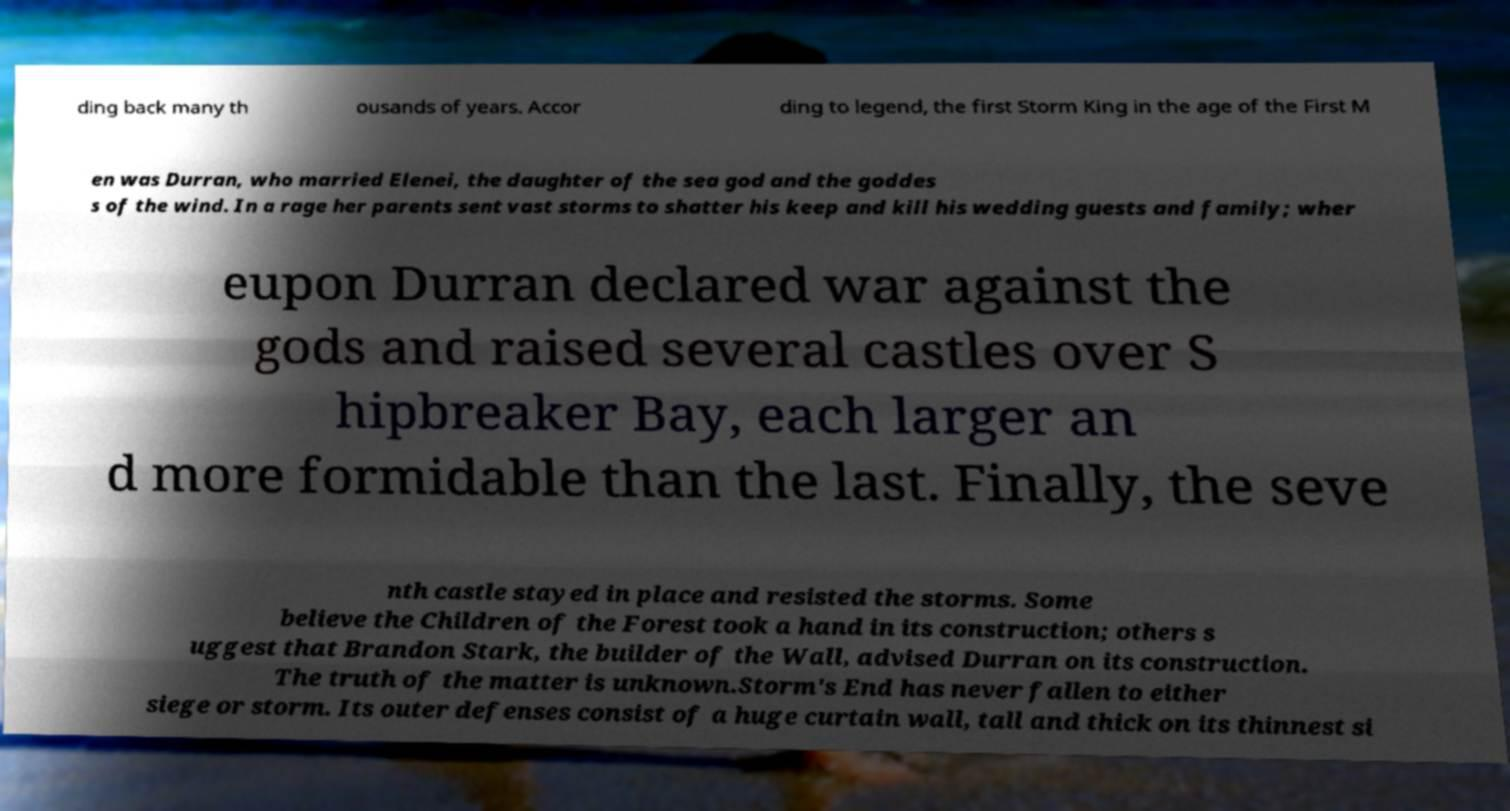Please read and relay the text visible in this image. What does it say? ding back many th ousands of years. Accor ding to legend, the first Storm King in the age of the First M en was Durran, who married Elenei, the daughter of the sea god and the goddes s of the wind. In a rage her parents sent vast storms to shatter his keep and kill his wedding guests and family; wher eupon Durran declared war against the gods and raised several castles over S hipbreaker Bay, each larger an d more formidable than the last. Finally, the seve nth castle stayed in place and resisted the storms. Some believe the Children of the Forest took a hand in its construction; others s uggest that Brandon Stark, the builder of the Wall, advised Durran on its construction. The truth of the matter is unknown.Storm's End has never fallen to either siege or storm. Its outer defenses consist of a huge curtain wall, tall and thick on its thinnest si 